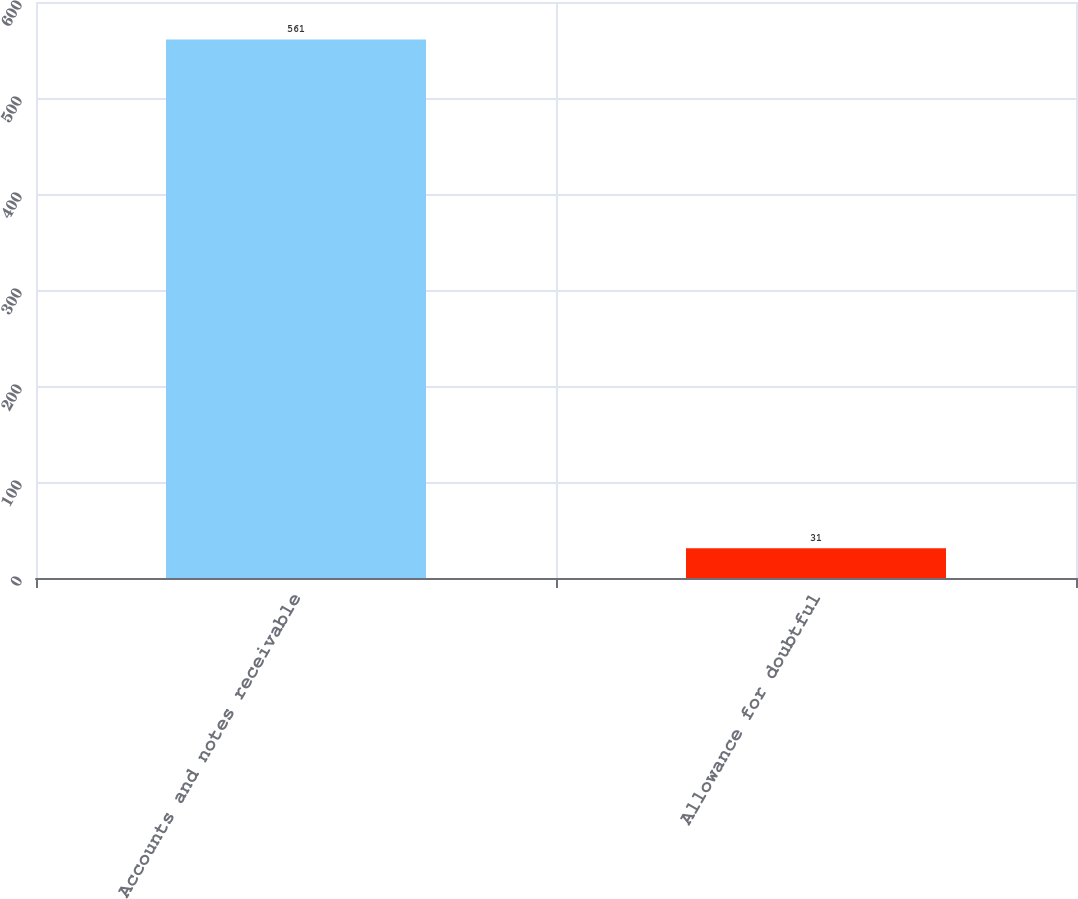<chart> <loc_0><loc_0><loc_500><loc_500><bar_chart><fcel>Accounts and notes receivable<fcel>Allowance for doubtful<nl><fcel>561<fcel>31<nl></chart> 